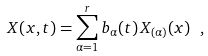Convert formula to latex. <formula><loc_0><loc_0><loc_500><loc_500>X ( x , t ) = \sum _ { \alpha = 1 } ^ { r } b _ { \alpha } ( t ) \, X _ { ( \alpha ) } ( x ) \ ,</formula> 